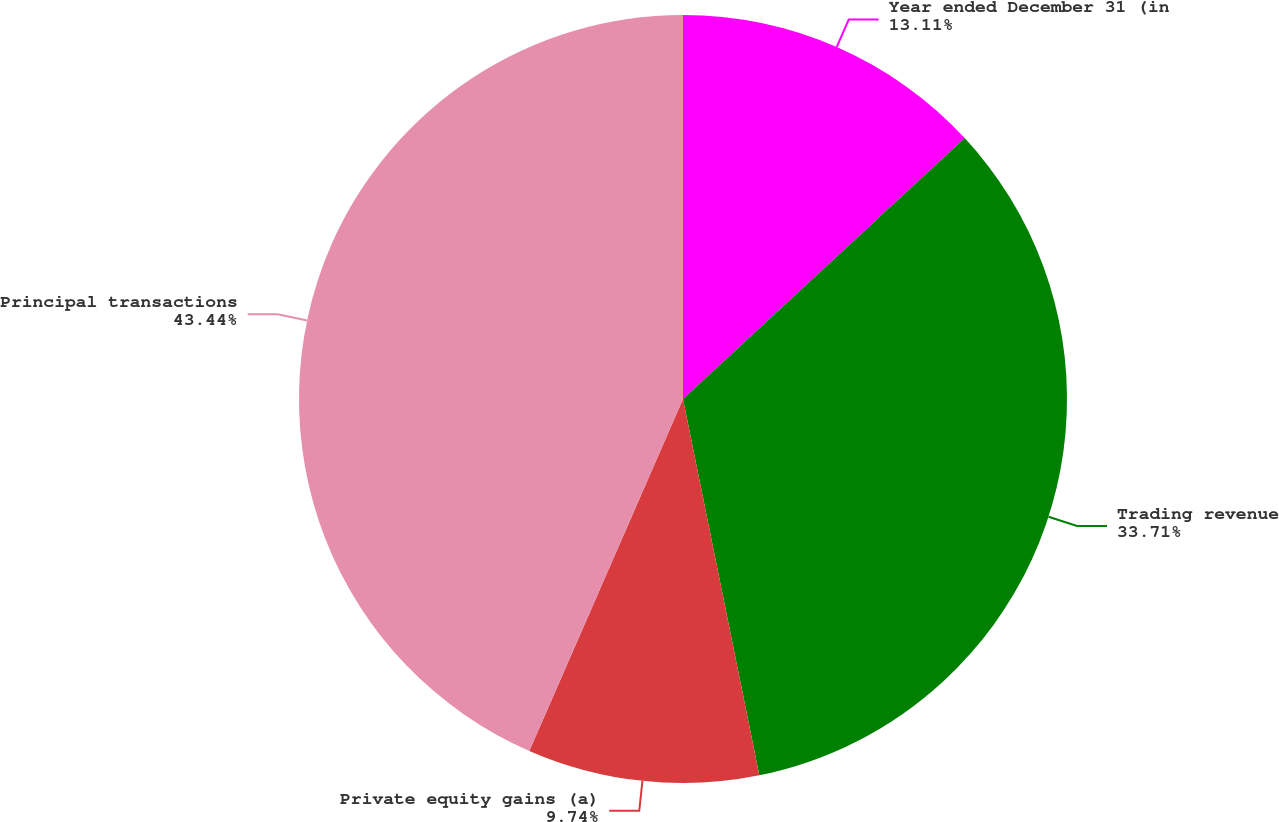Convert chart to OTSL. <chart><loc_0><loc_0><loc_500><loc_500><pie_chart><fcel>Year ended December 31 (in<fcel>Trading revenue<fcel>Private equity gains (a)<fcel>Principal transactions<nl><fcel>13.11%<fcel>33.71%<fcel>9.74%<fcel>43.45%<nl></chart> 